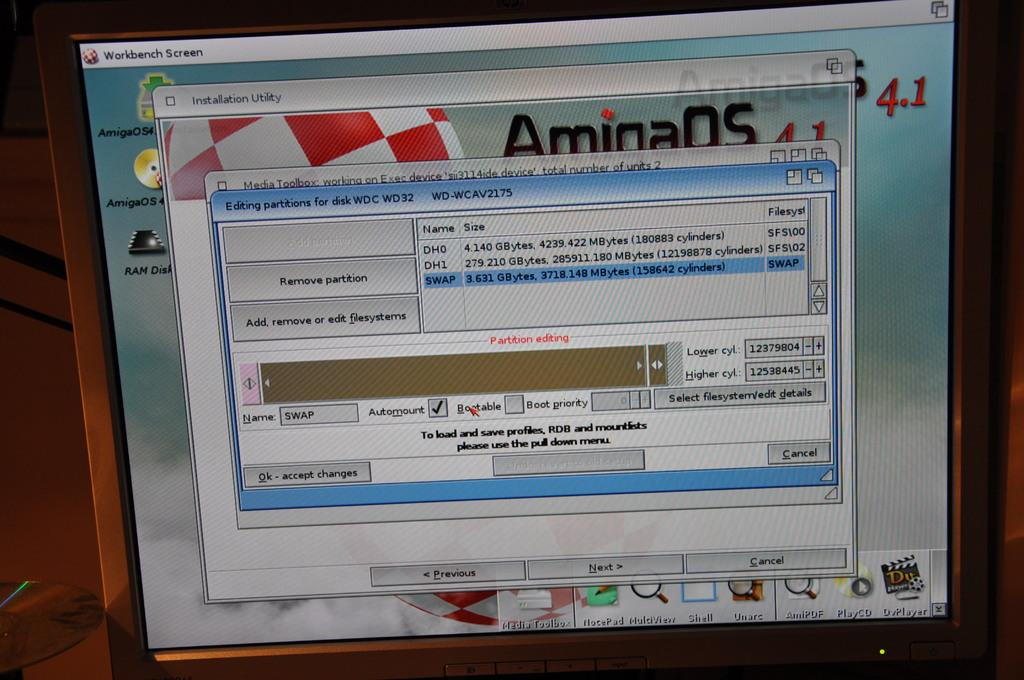<image>
Give a short and clear explanation of the subsequent image. A computer screen has the word AmioaOS on it. 